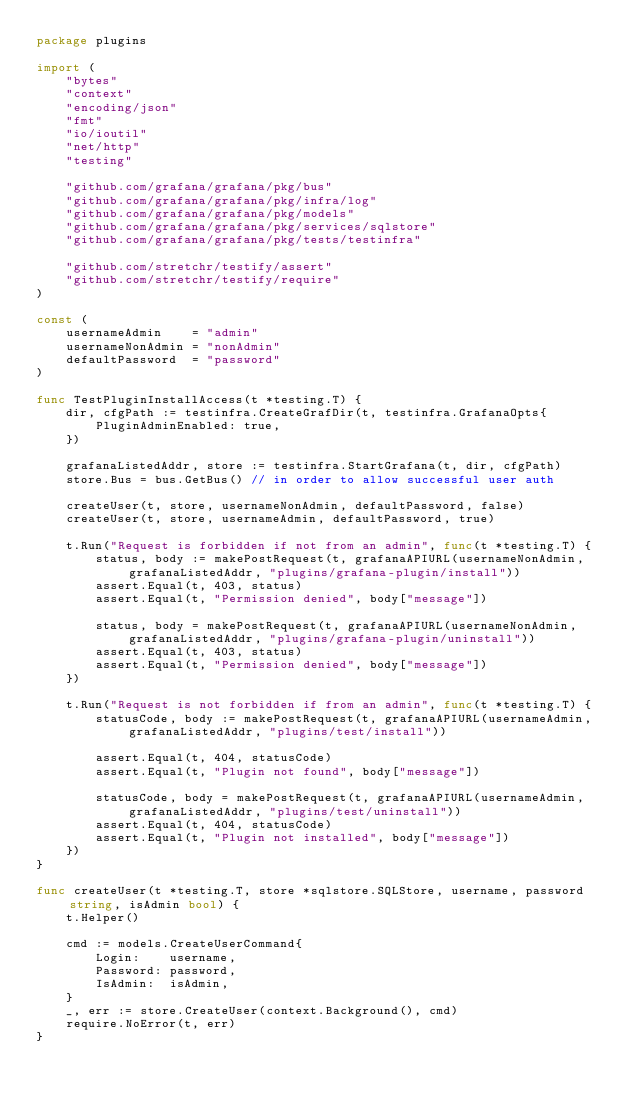<code> <loc_0><loc_0><loc_500><loc_500><_Go_>package plugins

import (
	"bytes"
	"context"
	"encoding/json"
	"fmt"
	"io/ioutil"
	"net/http"
	"testing"

	"github.com/grafana/grafana/pkg/bus"
	"github.com/grafana/grafana/pkg/infra/log"
	"github.com/grafana/grafana/pkg/models"
	"github.com/grafana/grafana/pkg/services/sqlstore"
	"github.com/grafana/grafana/pkg/tests/testinfra"

	"github.com/stretchr/testify/assert"
	"github.com/stretchr/testify/require"
)

const (
	usernameAdmin    = "admin"
	usernameNonAdmin = "nonAdmin"
	defaultPassword  = "password"
)

func TestPluginInstallAccess(t *testing.T) {
	dir, cfgPath := testinfra.CreateGrafDir(t, testinfra.GrafanaOpts{
		PluginAdminEnabled: true,
	})

	grafanaListedAddr, store := testinfra.StartGrafana(t, dir, cfgPath)
	store.Bus = bus.GetBus() // in order to allow successful user auth

	createUser(t, store, usernameNonAdmin, defaultPassword, false)
	createUser(t, store, usernameAdmin, defaultPassword, true)

	t.Run("Request is forbidden if not from an admin", func(t *testing.T) {
		status, body := makePostRequest(t, grafanaAPIURL(usernameNonAdmin, grafanaListedAddr, "plugins/grafana-plugin/install"))
		assert.Equal(t, 403, status)
		assert.Equal(t, "Permission denied", body["message"])

		status, body = makePostRequest(t, grafanaAPIURL(usernameNonAdmin, grafanaListedAddr, "plugins/grafana-plugin/uninstall"))
		assert.Equal(t, 403, status)
		assert.Equal(t, "Permission denied", body["message"])
	})

	t.Run("Request is not forbidden if from an admin", func(t *testing.T) {
		statusCode, body := makePostRequest(t, grafanaAPIURL(usernameAdmin, grafanaListedAddr, "plugins/test/install"))

		assert.Equal(t, 404, statusCode)
		assert.Equal(t, "Plugin not found", body["message"])

		statusCode, body = makePostRequest(t, grafanaAPIURL(usernameAdmin, grafanaListedAddr, "plugins/test/uninstall"))
		assert.Equal(t, 404, statusCode)
		assert.Equal(t, "Plugin not installed", body["message"])
	})
}

func createUser(t *testing.T, store *sqlstore.SQLStore, username, password string, isAdmin bool) {
	t.Helper()

	cmd := models.CreateUserCommand{
		Login:    username,
		Password: password,
		IsAdmin:  isAdmin,
	}
	_, err := store.CreateUser(context.Background(), cmd)
	require.NoError(t, err)
}
</code> 